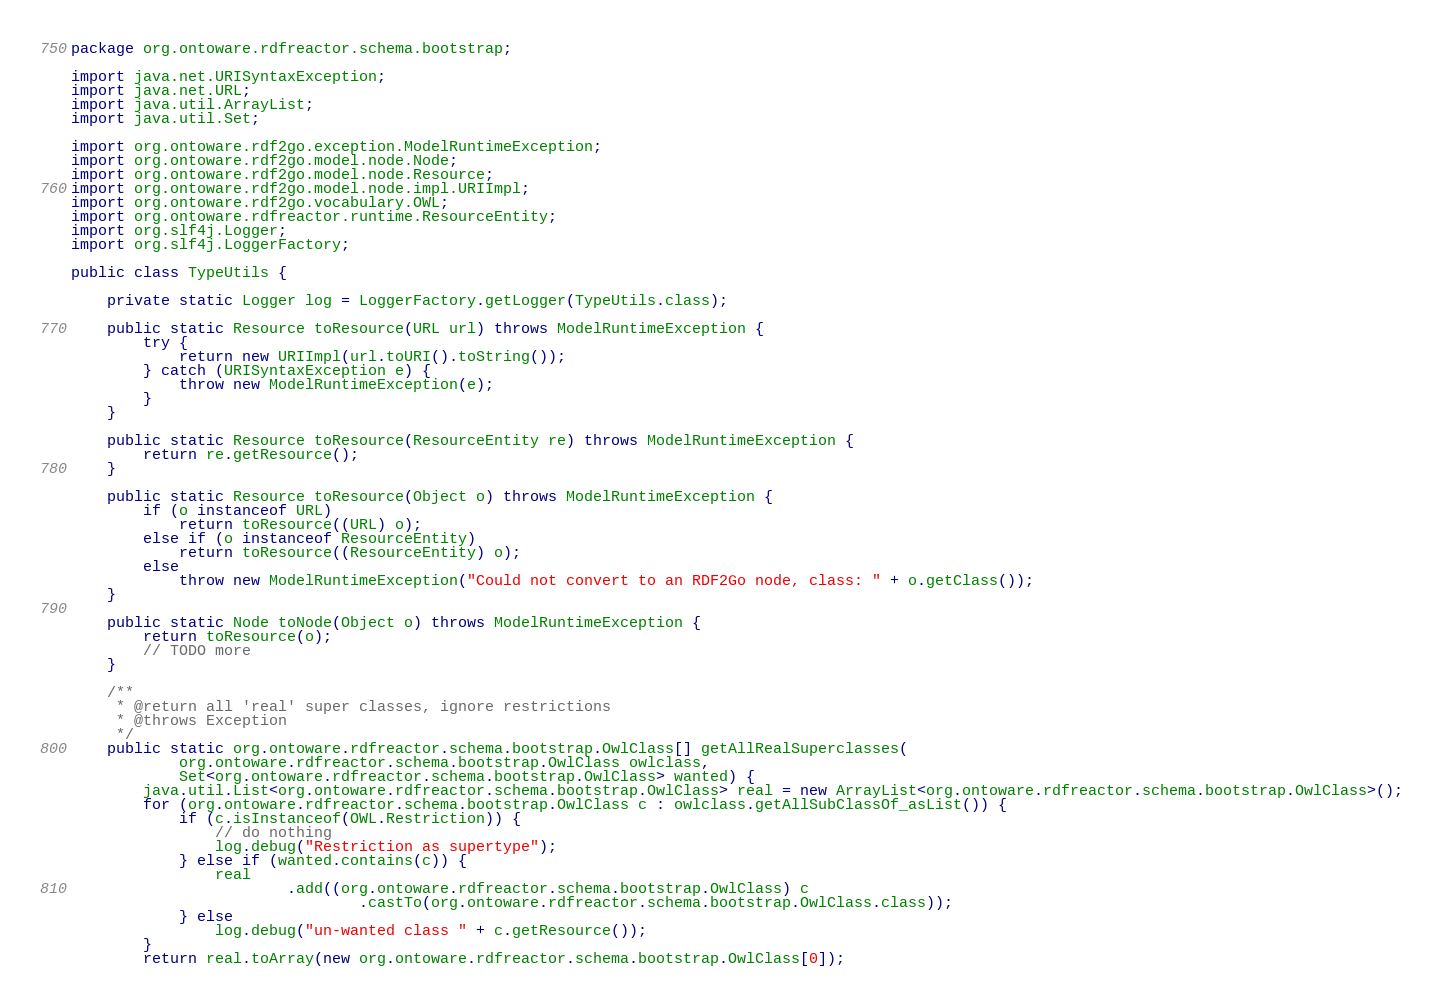<code> <loc_0><loc_0><loc_500><loc_500><_Java_>package org.ontoware.rdfreactor.schema.bootstrap;

import java.net.URISyntaxException;
import java.net.URL;
import java.util.ArrayList;
import java.util.Set;

import org.ontoware.rdf2go.exception.ModelRuntimeException;
import org.ontoware.rdf2go.model.node.Node;
import org.ontoware.rdf2go.model.node.Resource;
import org.ontoware.rdf2go.model.node.impl.URIImpl;
import org.ontoware.rdf2go.vocabulary.OWL;
import org.ontoware.rdfreactor.runtime.ResourceEntity;
import org.slf4j.Logger;
import org.slf4j.LoggerFactory;

public class TypeUtils {
	
	private static Logger log = LoggerFactory.getLogger(TypeUtils.class);

	public static Resource toResource(URL url) throws ModelRuntimeException {
		try {
			return new URIImpl(url.toURI().toString());
		} catch (URISyntaxException e) {
			throw new ModelRuntimeException(e);
		}
	}

	public static Resource toResource(ResourceEntity re) throws ModelRuntimeException {
		return re.getResource();
	}

	public static Resource toResource(Object o) throws ModelRuntimeException {
		if (o instanceof URL)
			return toResource((URL) o);
		else if (o instanceof ResourceEntity)
			return toResource((ResourceEntity) o);
		else
			throw new ModelRuntimeException("Could not convert to an RDF2Go node, class: " + o.getClass());
	}

	public static Node toNode(Object o) throws ModelRuntimeException {
		return toResource(o);
		// TODO more
	}
	
	/**
	 * @return all 'real' super classes, ignore restrictions
	 * @throws Exception
	 */
	public static org.ontoware.rdfreactor.schema.bootstrap.OwlClass[] getAllRealSuperclasses( 
			org.ontoware.rdfreactor.schema.bootstrap.OwlClass owlclass,
			Set<org.ontoware.rdfreactor.schema.bootstrap.OwlClass> wanted) {
		java.util.List<org.ontoware.rdfreactor.schema.bootstrap.OwlClass> real = new ArrayList<org.ontoware.rdfreactor.schema.bootstrap.OwlClass>();
		for (org.ontoware.rdfreactor.schema.bootstrap.OwlClass c : owlclass.getAllSubClassOf_asList()) {
			if (c.isInstanceof(OWL.Restriction)) {
				// do nothing
				log.debug("Restriction as supertype");
			} else if (wanted.contains(c)) {
				real
						.add((org.ontoware.rdfreactor.schema.bootstrap.OwlClass) c
								.castTo(org.ontoware.rdfreactor.schema.bootstrap.OwlClass.class));
			} else
				log.debug("un-wanted class " + c.getResource());
		}
		return real.toArray(new org.ontoware.rdfreactor.schema.bootstrap.OwlClass[0]);</code> 